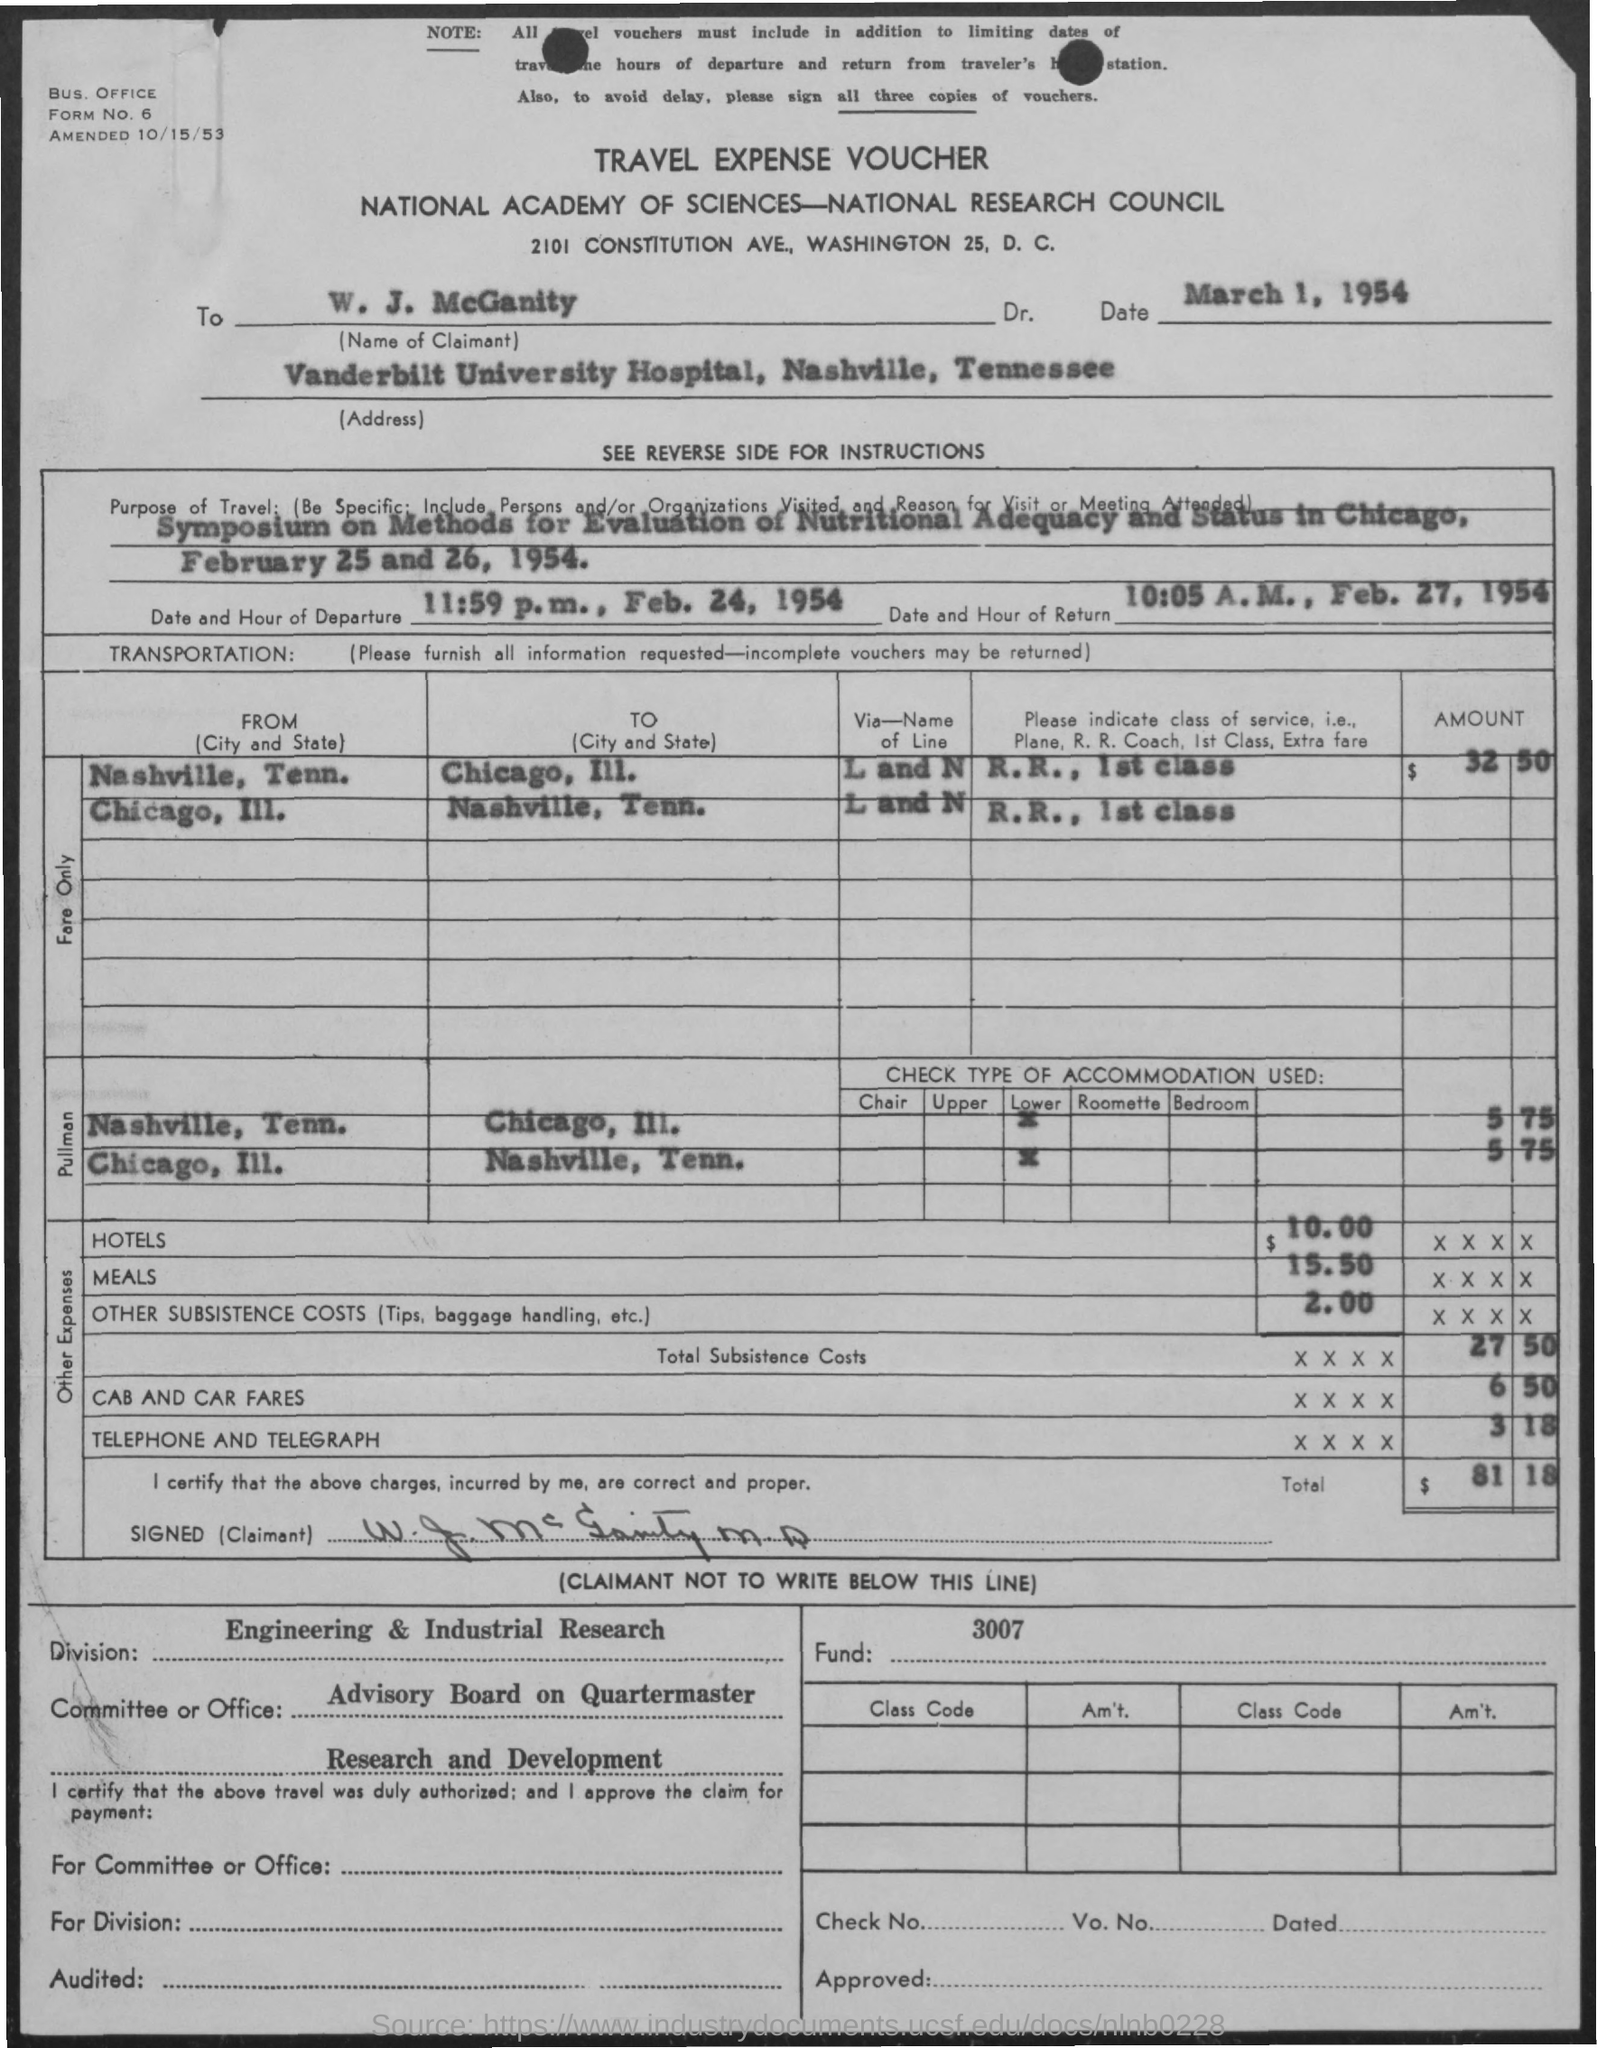Mention a couple of crucial points in this snapshot. The claimant's address is Vanderbilt University Hospital, located in Nashville, Tennessee. The name of the claimant is W. J. McGanity. The date and hour of departure is 11:59 p.m. on February 24, 1954. The total cost is $81.18. The travel expense voucher is what it is. 